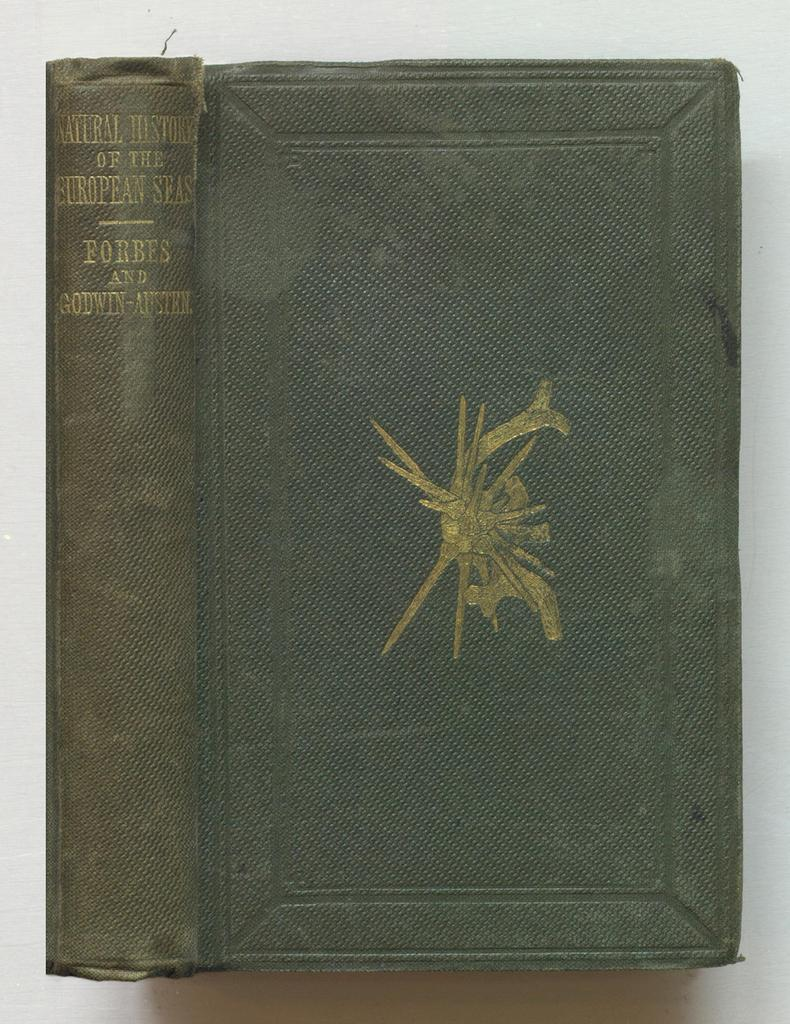<image>
Create a compact narrative representing the image presented. A old green book contains the history of the European seas. 